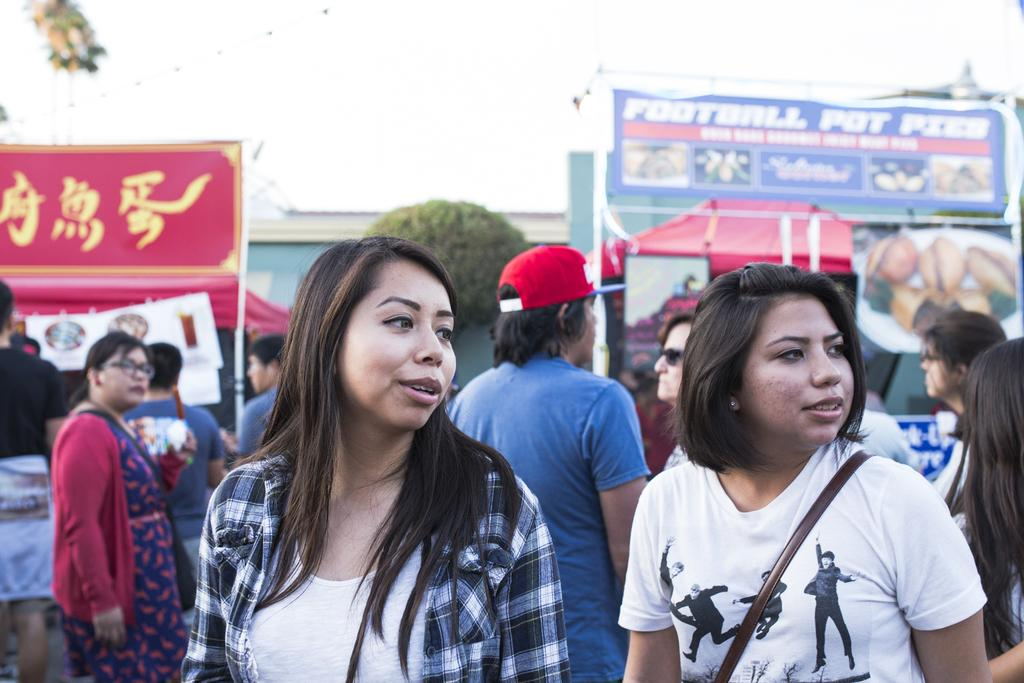Who or what can be seen in the image? There are people in the image. What type of structures are present in the image? There are stalls in the image. Is there any written information visible in the image? Yes, there is written text on a board. What type of natural elements can be seen in the image? There are trees in the image. What can be seen in the distance in the image? The sky is visible in the background of the image. How many children are playing in the image? There is no information about children playing in the image; it only mentions people in general. 